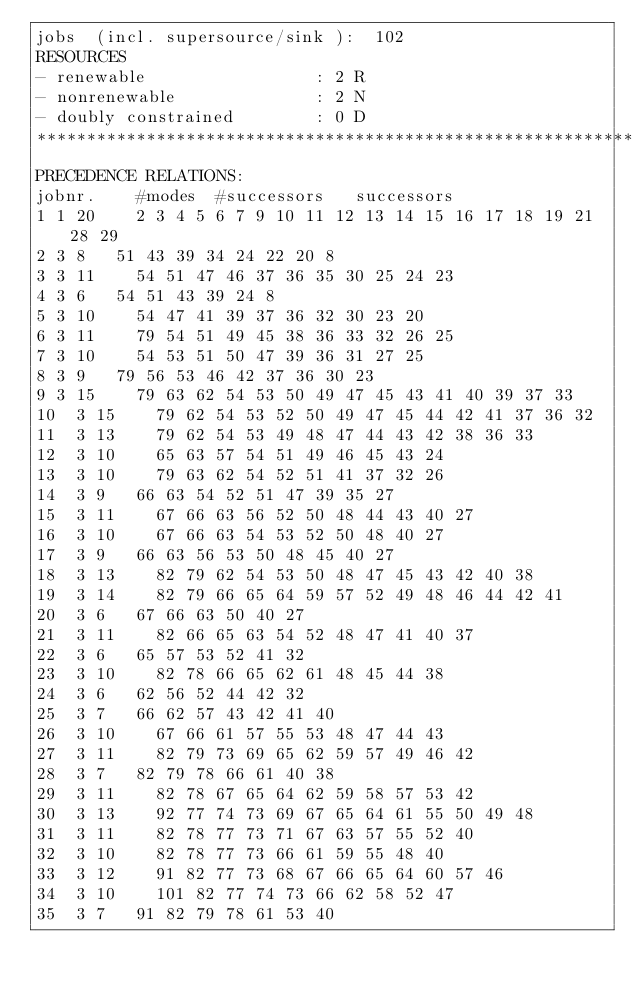<code> <loc_0><loc_0><loc_500><loc_500><_ObjectiveC_>jobs  (incl. supersource/sink ):	102
RESOURCES
- renewable                 : 2 R
- nonrenewable              : 2 N
- doubly constrained        : 0 D
************************************************************************
PRECEDENCE RELATIONS:
jobnr.    #modes  #successors   successors
1	1	20		2 3 4 5 6 7 9 10 11 12 13 14 15 16 17 18 19 21 28 29 
2	3	8		51 43 39 34 24 22 20 8 
3	3	11		54 51 47 46 37 36 35 30 25 24 23 
4	3	6		54 51 43 39 24 8 
5	3	10		54 47 41 39 37 36 32 30 23 20 
6	3	11		79 54 51 49 45 38 36 33 32 26 25 
7	3	10		54 53 51 50 47 39 36 31 27 25 
8	3	9		79 56 53 46 42 37 36 30 23 
9	3	15		79 63 62 54 53 50 49 47 45 43 41 40 39 37 33 
10	3	15		79 62 54 53 52 50 49 47 45 44 42 41 37 36 32 
11	3	13		79 62 54 53 49 48 47 44 43 42 38 36 33 
12	3	10		65 63 57 54 51 49 46 45 43 24 
13	3	10		79 63 62 54 52 51 41 37 32 26 
14	3	9		66 63 54 52 51 47 39 35 27 
15	3	11		67 66 63 56 52 50 48 44 43 40 27 
16	3	10		67 66 63 54 53 52 50 48 40 27 
17	3	9		66 63 56 53 50 48 45 40 27 
18	3	13		82 79 62 54 53 50 48 47 45 43 42 40 38 
19	3	14		82 79 66 65 64 59 57 52 49 48 46 44 42 41 
20	3	6		67 66 63 50 40 27 
21	3	11		82 66 65 63 54 52 48 47 41 40 37 
22	3	6		65 57 53 52 41 32 
23	3	10		82 78 66 65 62 61 48 45 44 38 
24	3	6		62 56 52 44 42 32 
25	3	7		66 62 57 43 42 41 40 
26	3	10		67 66 61 57 55 53 48 47 44 43 
27	3	11		82 79 73 69 65 62 59 57 49 46 42 
28	3	7		82 79 78 66 61 40 38 
29	3	11		82 78 67 65 64 62 59 58 57 53 42 
30	3	13		92 77 74 73 69 67 65 64 61 55 50 49 48 
31	3	11		82 78 77 73 71 67 63 57 55 52 40 
32	3	10		82 78 77 73 66 61 59 55 48 40 
33	3	12		91 82 77 73 68 67 66 65 64 60 57 46 
34	3	10		101 82 77 74 73 66 62 58 52 47 
35	3	7		91 82 79 78 61 53 40 </code> 